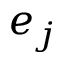Convert formula to latex. <formula><loc_0><loc_0><loc_500><loc_500>e _ { j }</formula> 